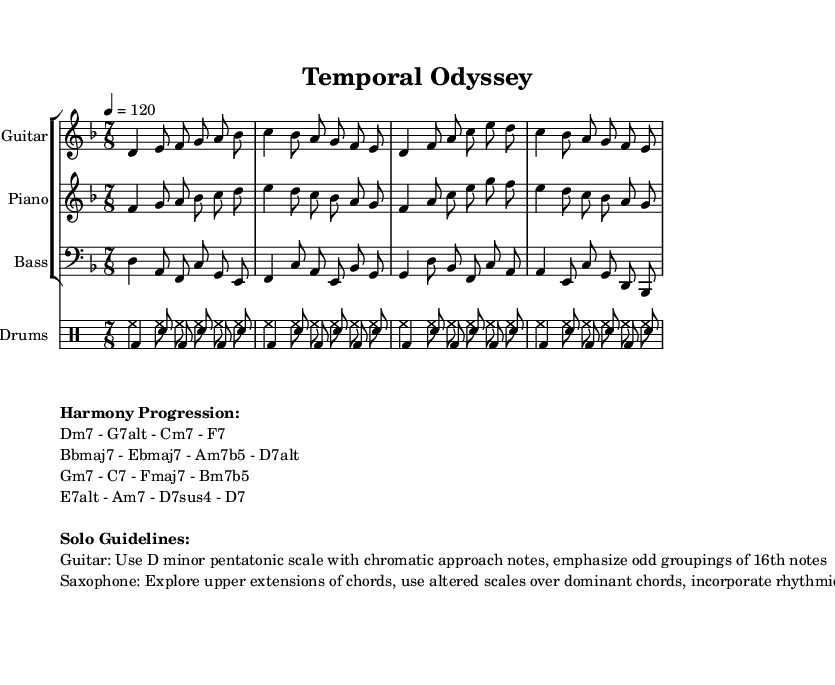What is the key signature of this music? The key signature is indicated by the "\key" command in the global settings of the code, which is "d \minor". This means the piece is in the key of D minor.
Answer: D minor What is the time signature of this piece? The time signature is listed as "\time 7/8" in the global settings, which indicates that the music is structured in seven beats per measure, each beat being an eighth note.
Answer: 7/8 What is the specified tempo marking? The tempo is indicated by "\tempo 4 = 120", which means to play at a speed of 120 beats per minute, with a quarter note getting one beat.
Answer: 120 How many measures does the guitar theme have? The guitar theme consists of four lines, and each line has four measures, totaling 16 measures. However, the question asks for a direct count, which is 4 lines contributing to the measure count, effectively pointing to the fact that each theme section is build up to 4 measures rather than the aggregate.
Answer: 4 What type of scale is suggested for the guitar solo? The solo guideline for guitar indicates the use of the "D minor pentatonic scale with chromatic approach notes", which describes the specific scale to be employed during the improvisation.
Answer: D minor pentatonic What type of chords does the saxophone player explore? The guidelines specify that the saxophone should explore "upper extensions of chords", indicating a focus on adding higher extensions to the basic chords during improvisation.
Answer: Upper extensions What rhythmic grouping is recommended for the guitar solo? According to the guidelines for the guitar solo, it suggests emphasizing "odd groupings of 16th notes", which involves focusing on unconventional patterns when playing.
Answer: Odd groupings of 16th notes 